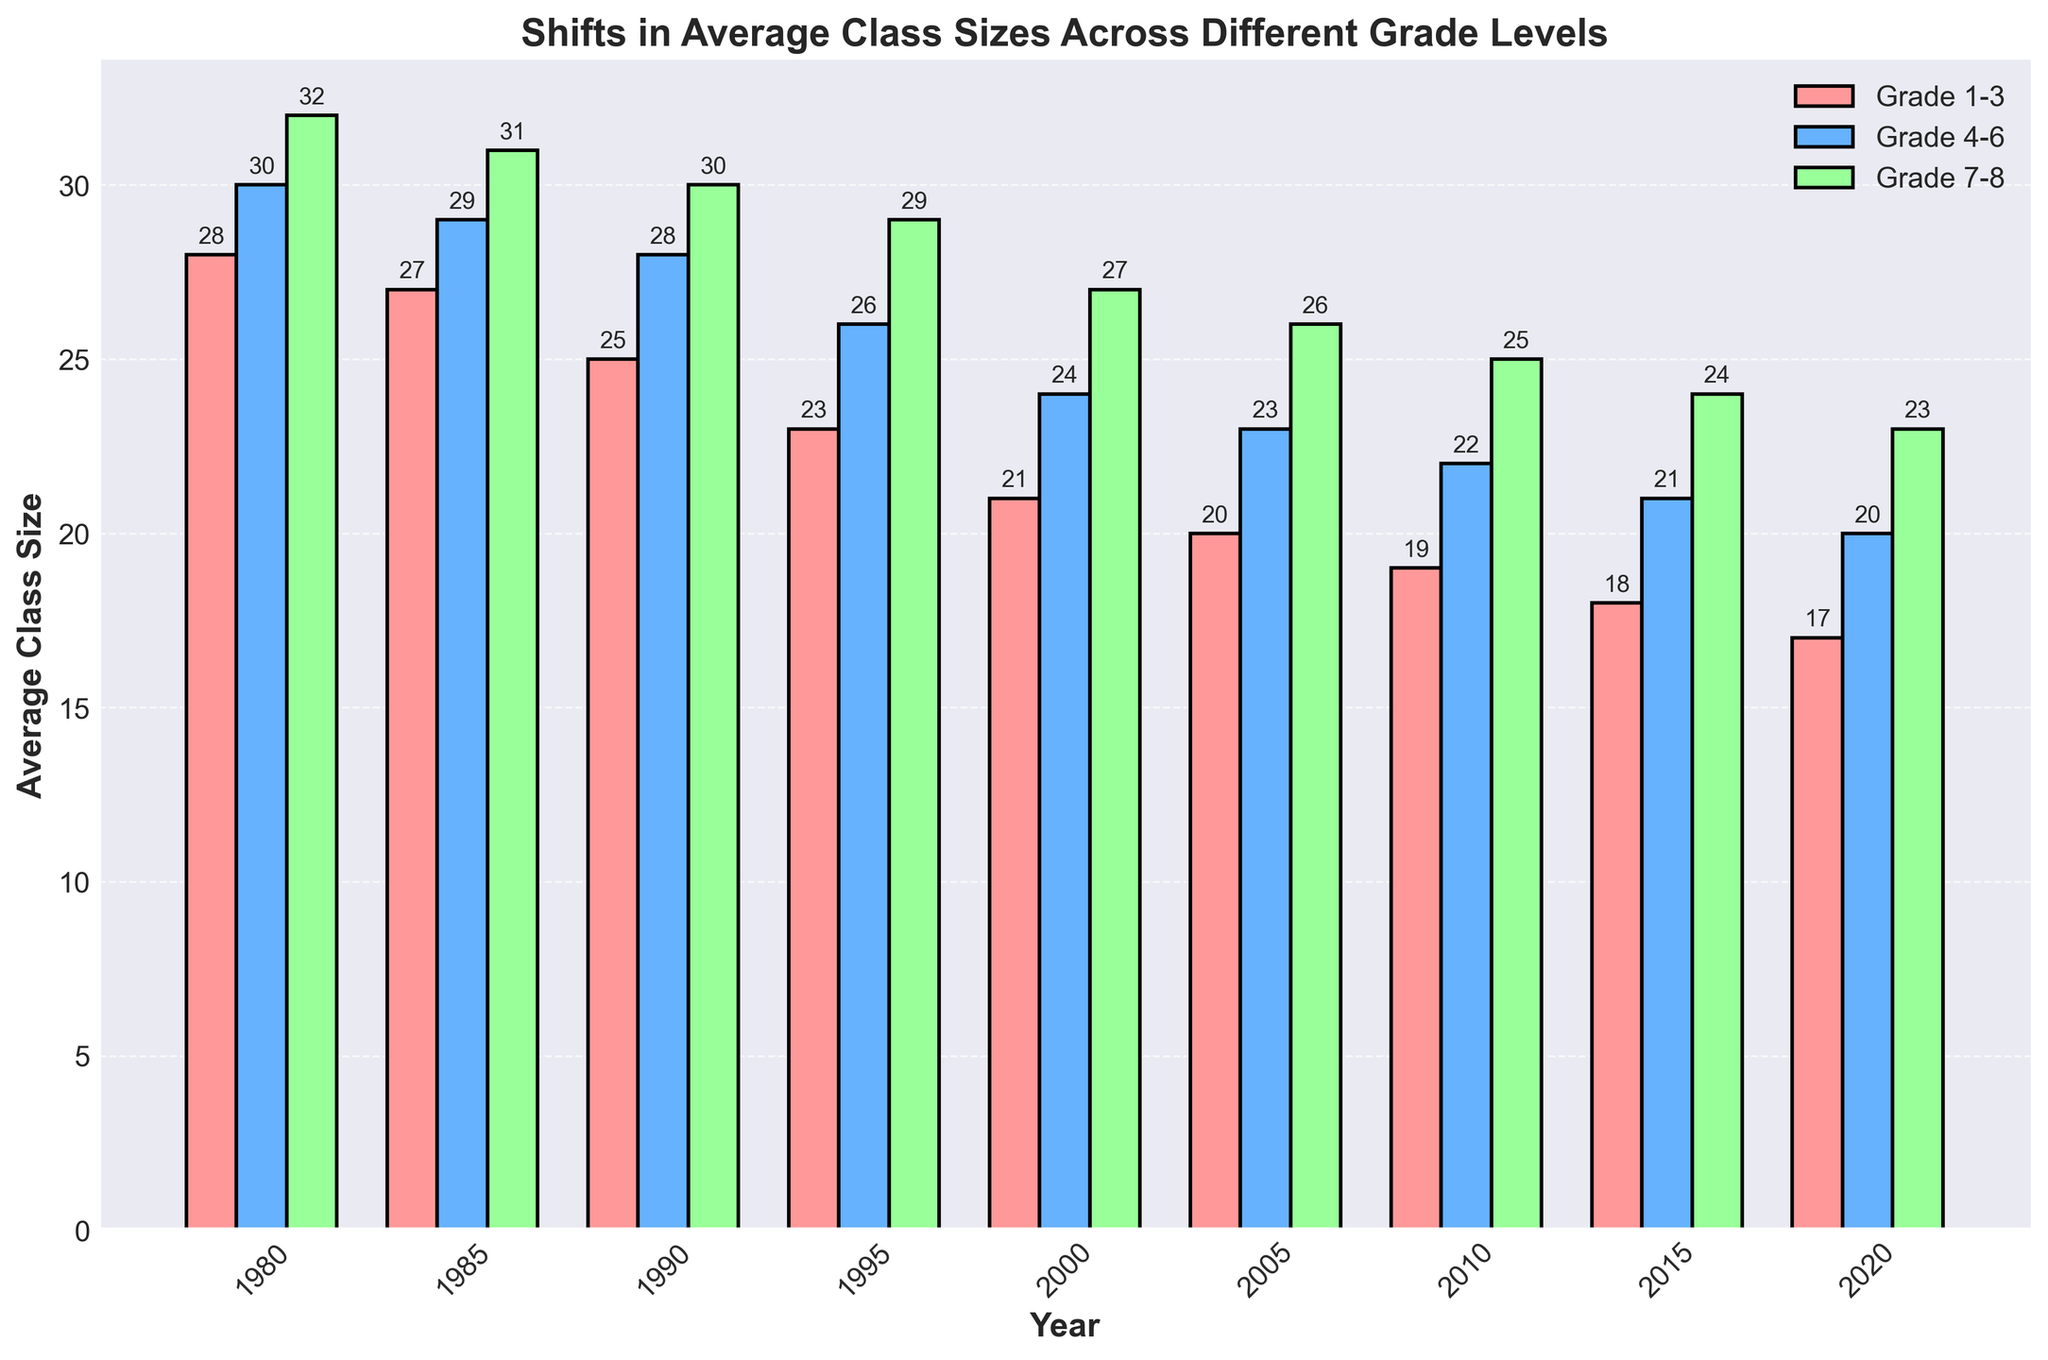How did the average class size for Grade 1-3 change from 1980 to 2020? Look at the bars for Grade 1-3 for 1980 and 2020. The height for 1980 represents 28 students, and for 2020 it represents 17 students. The change is 28 - 17 = 11 students.
Answer: It decreased by 11 students Which grade level had the smallest average class size in 2000? Compare the heights of the bars for each grade level in the year 2000. The bars for Grade 1-3, Grade 4-6, and Grade 7-8 represent 21, 24, and 27 students respectively. Grade 1-3 has the smallest value.
Answer: Grade 1-3 In which year did the average class size for Grade 4-6 drop below 25 students? Observe the trend for the Grade 4-6 bars and find the first year where the height is below 25. This occurs in the year 2000 when the height for Grade 4-6 is 24.
Answer: 2000 What is the difference in average class size between Grade 4-6 and Grade 7-8 in 2015? Look at the heights of the bars for Grade 4-6 and Grade 7-8 in 2015. Grade 4-6 is 21, and Grade 7-8 is 24. The difference is 24 - 21 = 3.
Answer: 3 students Which grade level experienced the largest decrease in average class size from 1980 to 2020? Calculate the change for each grade level from 1980 to 2020: Grade 1-3 (28 to 17), Grade 4-6 (30 to 20), and Grade 7-8 (32 to 23). The changes are 11, 10, and 9 respectively. Grade 1-3 had the largest decrease of 11.
Answer: Grade 1-3 What year shows the same average class size for Grade 4-6 and Grade 7-8? Study the bars for Grade 4-6 and Grade 7-8 across years to find the year(s) where their heights are equal. For 1985, both Grade 4-6 and Grade 7-8 have a height of 29.
Answer: 1985 Between 1980 and 2000, which grade level had the most consistent decrease in average class size? Examine the decrease per interval for each grade level. Compute the decrease for each interval and note the consistency: Grade 1-3 drops range from 1 to 2, Grade 4-6 from 1 to 2, and Grade 7-8 from 1 to 2, but Grade 1-3 consistently decreases without fluctuation.
Answer: Grade 1-3 How many years did it take for the average class size of Grade 7-8 to decrease by 3 students from 1980 levels? Find the years when the decrease from 32 students begins and count until a 3-student decrease is observed, i.e., reaching 29 students. By 1995, Grade 7-8 is reduced to 29.
Answer: 15 years What is the average class size across all grade levels in 1990? Sum the average class sizes for all grades in 1990: 25 (Grade 1-3) + 28 (Grade 4-6) + 30 (Grade 7-8) = 83. Then divide by the number of grade levels, which is 3. So, the average is 83 / 3 ≈ 27.7.
Answer: 27.7 students 